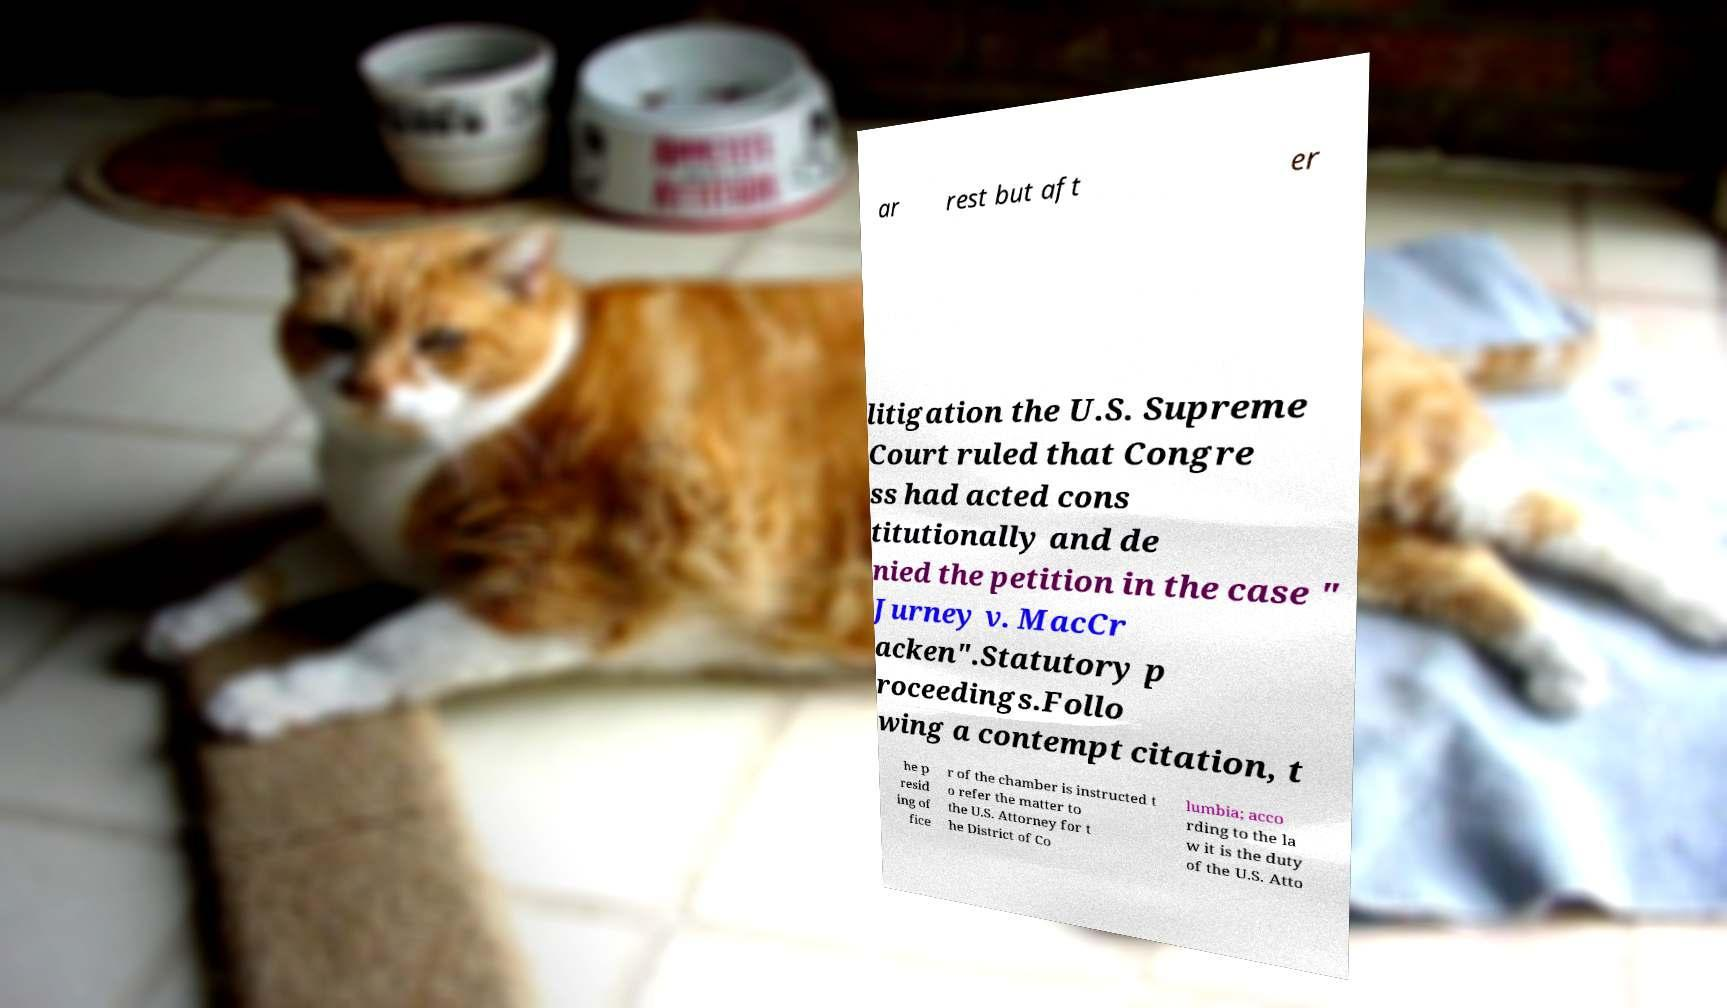Please identify and transcribe the text found in this image. ar rest but aft er litigation the U.S. Supreme Court ruled that Congre ss had acted cons titutionally and de nied the petition in the case " Jurney v. MacCr acken".Statutory p roceedings.Follo wing a contempt citation, t he p resid ing of fice r of the chamber is instructed t o refer the matter to the U.S. Attorney for t he District of Co lumbia; acco rding to the la w it is the duty of the U.S. Atto 